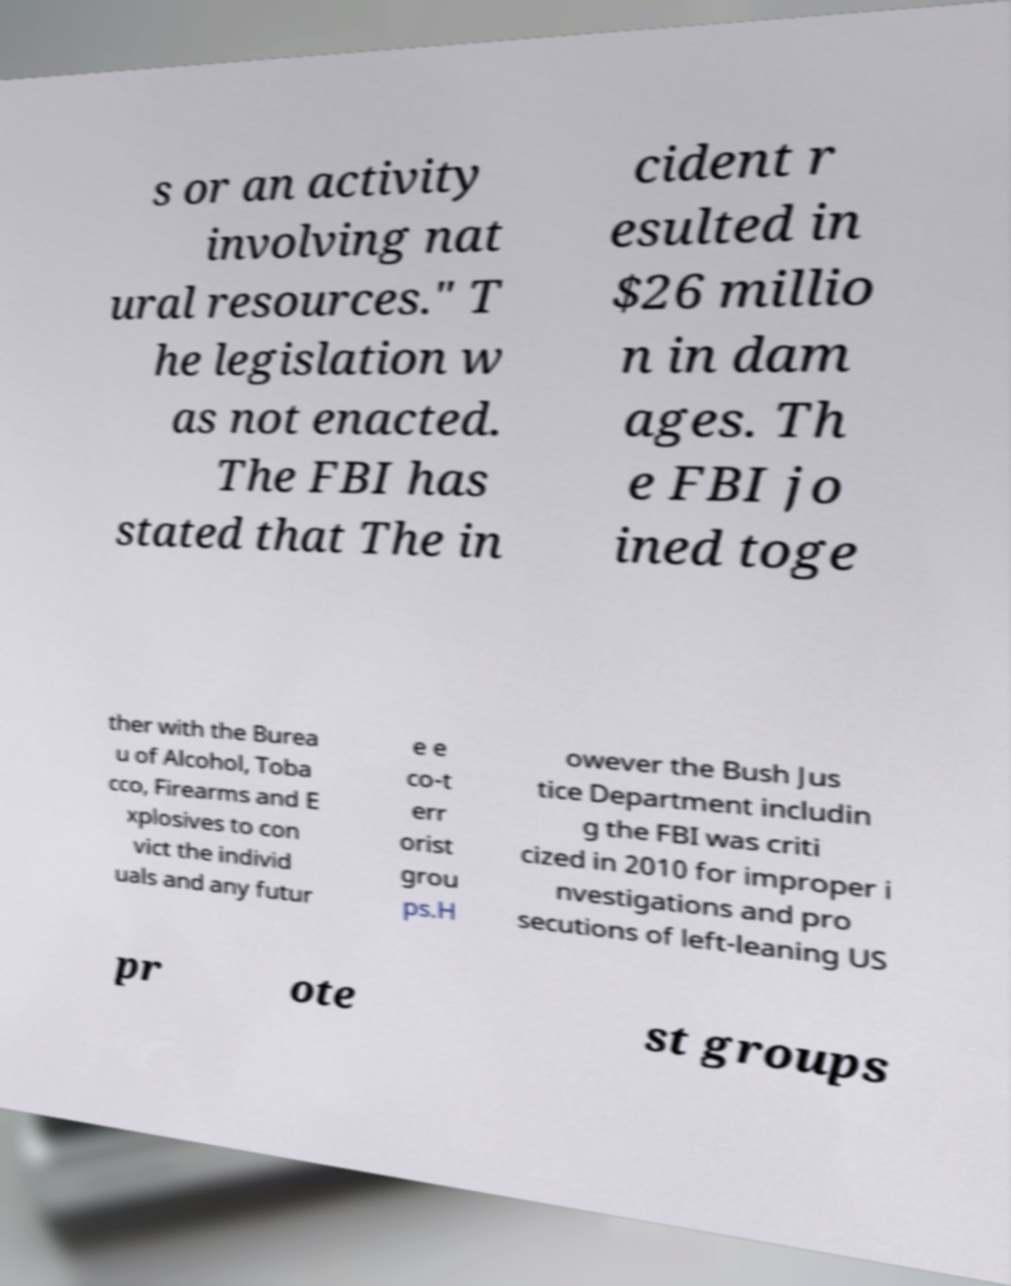Can you read and provide the text displayed in the image?This photo seems to have some interesting text. Can you extract and type it out for me? s or an activity involving nat ural resources." T he legislation w as not enacted. The FBI has stated that The in cident r esulted in $26 millio n in dam ages. Th e FBI jo ined toge ther with the Burea u of Alcohol, Toba cco, Firearms and E xplosives to con vict the individ uals and any futur e e co-t err orist grou ps.H owever the Bush Jus tice Department includin g the FBI was criti cized in 2010 for improper i nvestigations and pro secutions of left-leaning US pr ote st groups 